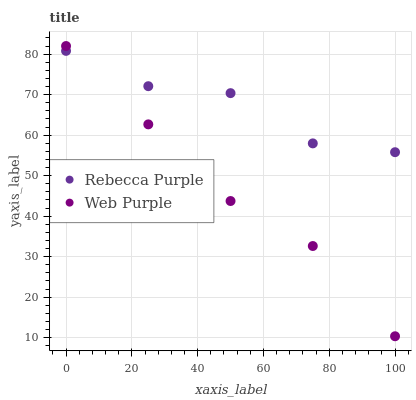Does Web Purple have the minimum area under the curve?
Answer yes or no. Yes. Does Rebecca Purple have the maximum area under the curve?
Answer yes or no. Yes. Does Rebecca Purple have the minimum area under the curve?
Answer yes or no. No. Is Web Purple the smoothest?
Answer yes or no. Yes. Is Rebecca Purple the roughest?
Answer yes or no. Yes. Is Rebecca Purple the smoothest?
Answer yes or no. No. Does Web Purple have the lowest value?
Answer yes or no. Yes. Does Rebecca Purple have the lowest value?
Answer yes or no. No. Does Web Purple have the highest value?
Answer yes or no. Yes. Does Rebecca Purple have the highest value?
Answer yes or no. No. Does Web Purple intersect Rebecca Purple?
Answer yes or no. Yes. Is Web Purple less than Rebecca Purple?
Answer yes or no. No. Is Web Purple greater than Rebecca Purple?
Answer yes or no. No. 